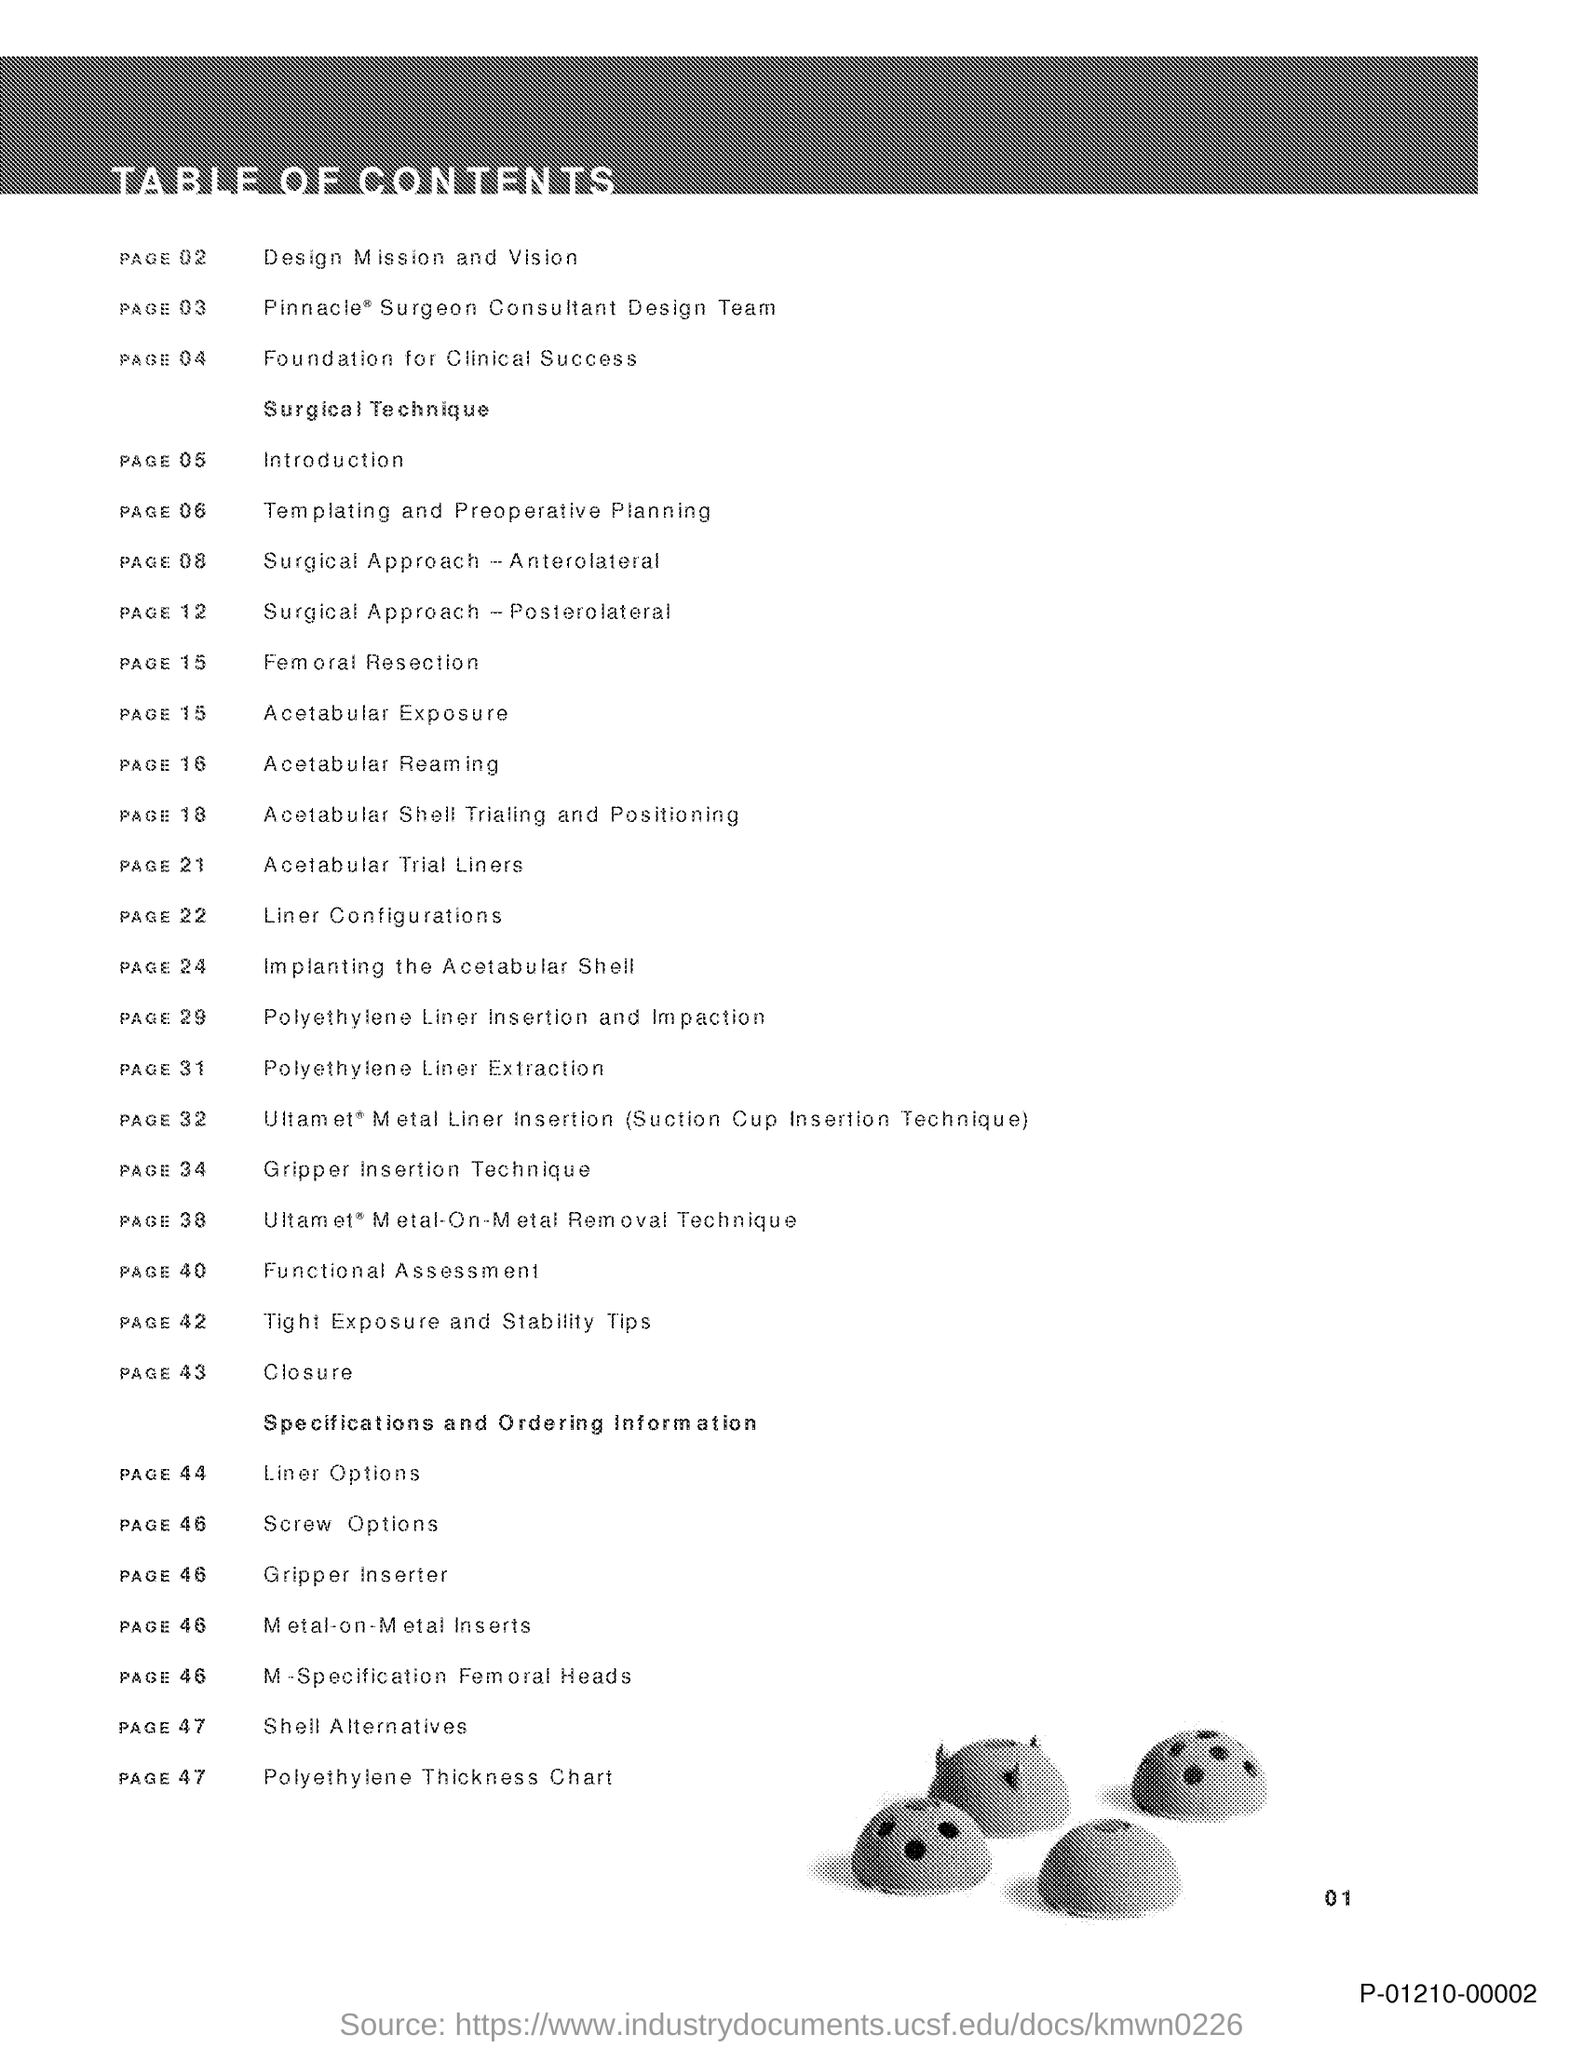What is the title of the document?
Ensure brevity in your answer.  TABLE OF CONTENTS. Introduction is in which page?
Make the answer very short. Page 05. Liner options is in which page?
Ensure brevity in your answer.  Page 44. 